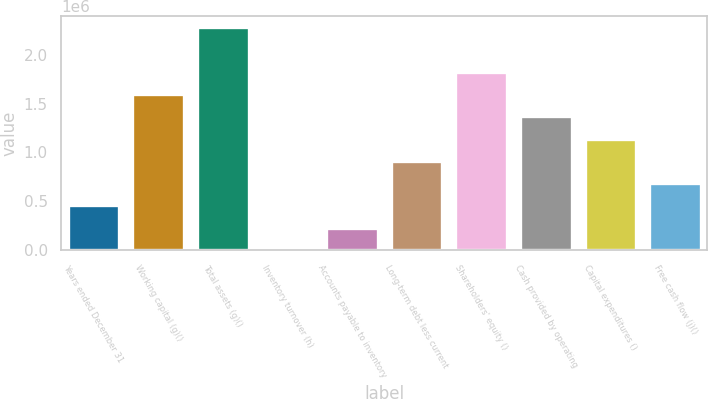Convert chart. <chart><loc_0><loc_0><loc_500><loc_500><bar_chart><fcel>Years ended December 31<fcel>Working capital (g)()<fcel>Total assets (g)()<fcel>Inventory turnover (h)<fcel>Accounts payable to inventory<fcel>Long-term debt less current<fcel>Shareholders' equity ()<fcel>Cash provided by operating<fcel>Capital expenditures ()<fcel>Free cash flow (j)()<nl><fcel>455949<fcel>1.59582e+06<fcel>2.27974e+06<fcel>1.6<fcel>227975<fcel>911896<fcel>1.82379e+06<fcel>1.36784e+06<fcel>1.13987e+06<fcel>683922<nl></chart> 